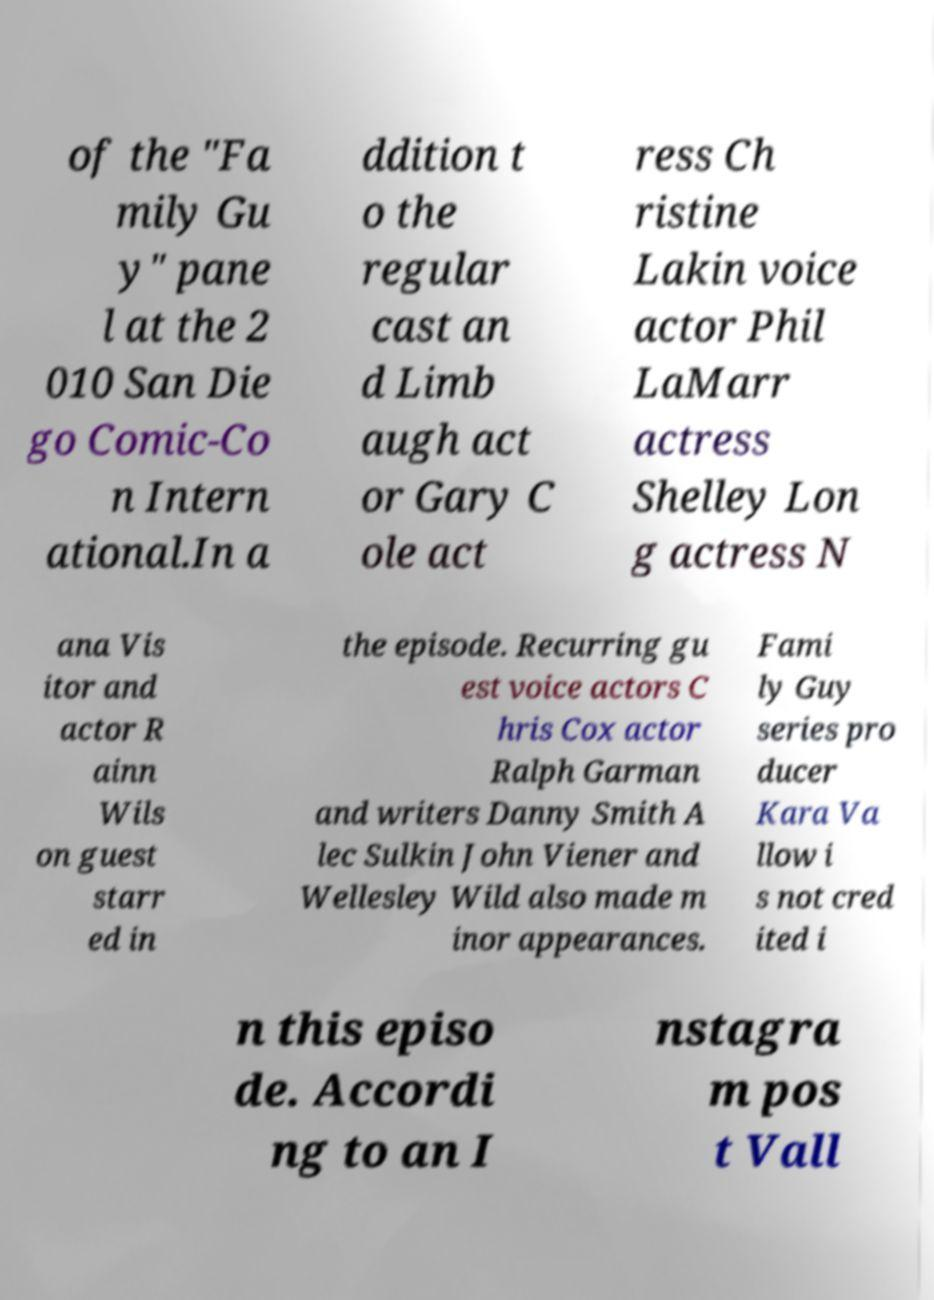For documentation purposes, I need the text within this image transcribed. Could you provide that? of the "Fa mily Gu y" pane l at the 2 010 San Die go Comic-Co n Intern ational.In a ddition t o the regular cast an d Limb augh act or Gary C ole act ress Ch ristine Lakin voice actor Phil LaMarr actress Shelley Lon g actress N ana Vis itor and actor R ainn Wils on guest starr ed in the episode. Recurring gu est voice actors C hris Cox actor Ralph Garman and writers Danny Smith A lec Sulkin John Viener and Wellesley Wild also made m inor appearances. Fami ly Guy series pro ducer Kara Va llow i s not cred ited i n this episo de. Accordi ng to an I nstagra m pos t Vall 